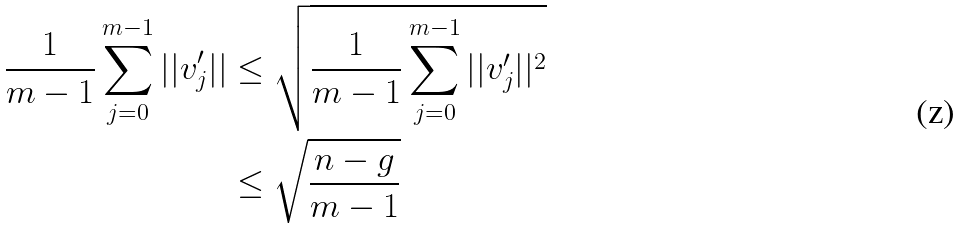Convert formula to latex. <formula><loc_0><loc_0><loc_500><loc_500>\frac { 1 } { m - 1 } \sum _ { j = 0 } ^ { m - 1 } | | v _ { j } ^ { \prime } | | & \leq \sqrt { \frac { 1 } { m - 1 } \sum _ { j = 0 } ^ { m - 1 } | | v _ { j } ^ { \prime } | | ^ { 2 } } \\ & \leq \sqrt { \frac { n - g } { m - 1 } }</formula> 